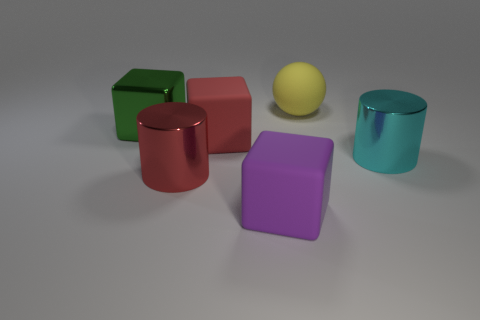How many other purple matte blocks have the same size as the purple rubber cube?
Your answer should be compact. 0. Do the large block on the left side of the red metal object and the yellow sphere have the same material?
Give a very brief answer. No. Is there a big gray block?
Your response must be concise. No. The sphere that is made of the same material as the large red cube is what size?
Keep it short and to the point. Large. Are there any big matte spheres of the same color as the large metallic block?
Make the answer very short. No. Do the object on the right side of the big yellow matte object and the big cylinder that is left of the large yellow matte object have the same color?
Your answer should be compact. No. Are there any big purple blocks that have the same material as the cyan thing?
Ensure brevity in your answer.  No. What color is the large shiny cube?
Your answer should be very brief. Green. What size is the metallic object right of the matte thing that is behind the metal thing that is behind the cyan metallic object?
Ensure brevity in your answer.  Large. How many other things are there of the same shape as the big green shiny object?
Give a very brief answer. 2. 